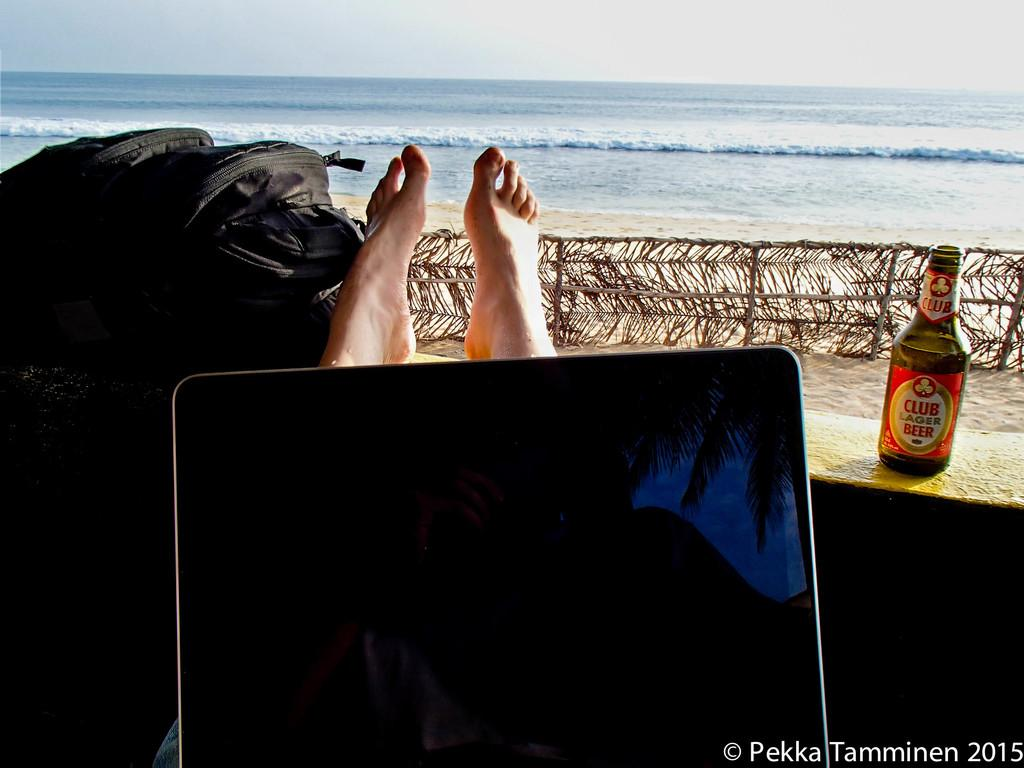What is the person in the image using? There is a laptop on a person's lap in the image. What else can be seen in the image besides the laptop? There is a bag and a beer bottle on the right side of the image. What part of the person's body is visible in the image? Two legs are visible in the image. What is the setting of the image? A sea is present in the image. What type of observation can be made about the owl in the image? There is no owl present in the image. Where is the drawer located in the image? There is no drawer present in the image. 